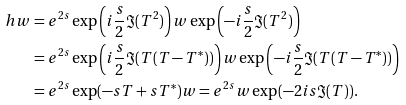<formula> <loc_0><loc_0><loc_500><loc_500>\ h w & = e ^ { 2 s } \exp \left ( i \frac { s } { 2 } \Im ( T ^ { 2 } ) \right ) w \exp \left ( - i \frac { s } { 2 } \Im ( T ^ { 2 } ) \right ) \\ & = e ^ { 2 s } \exp \left ( i \frac { s } { 2 } \Im ( T ( T - T ^ { * } ) ) \right ) w \exp \left ( - i \frac { s } { 2 } \Im ( T ( T - T ^ { * } ) ) \right ) \\ & = e ^ { 2 s } \exp ( - s T + s T ^ { * } ) w = e ^ { 2 s } w \exp ( - 2 i s \Im ( T ) ) .</formula> 